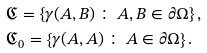Convert formula to latex. <formula><loc_0><loc_0><loc_500><loc_500>& { \mathfrak C } = \left \{ \gamma ( A , B ) \, \colon \, A , B \in \partial \Omega \right \} , \\ & { \mathfrak C _ { 0 } } = \left \{ \gamma ( A , A ) \, \colon \, A \in \partial \Omega \right \} .</formula> 